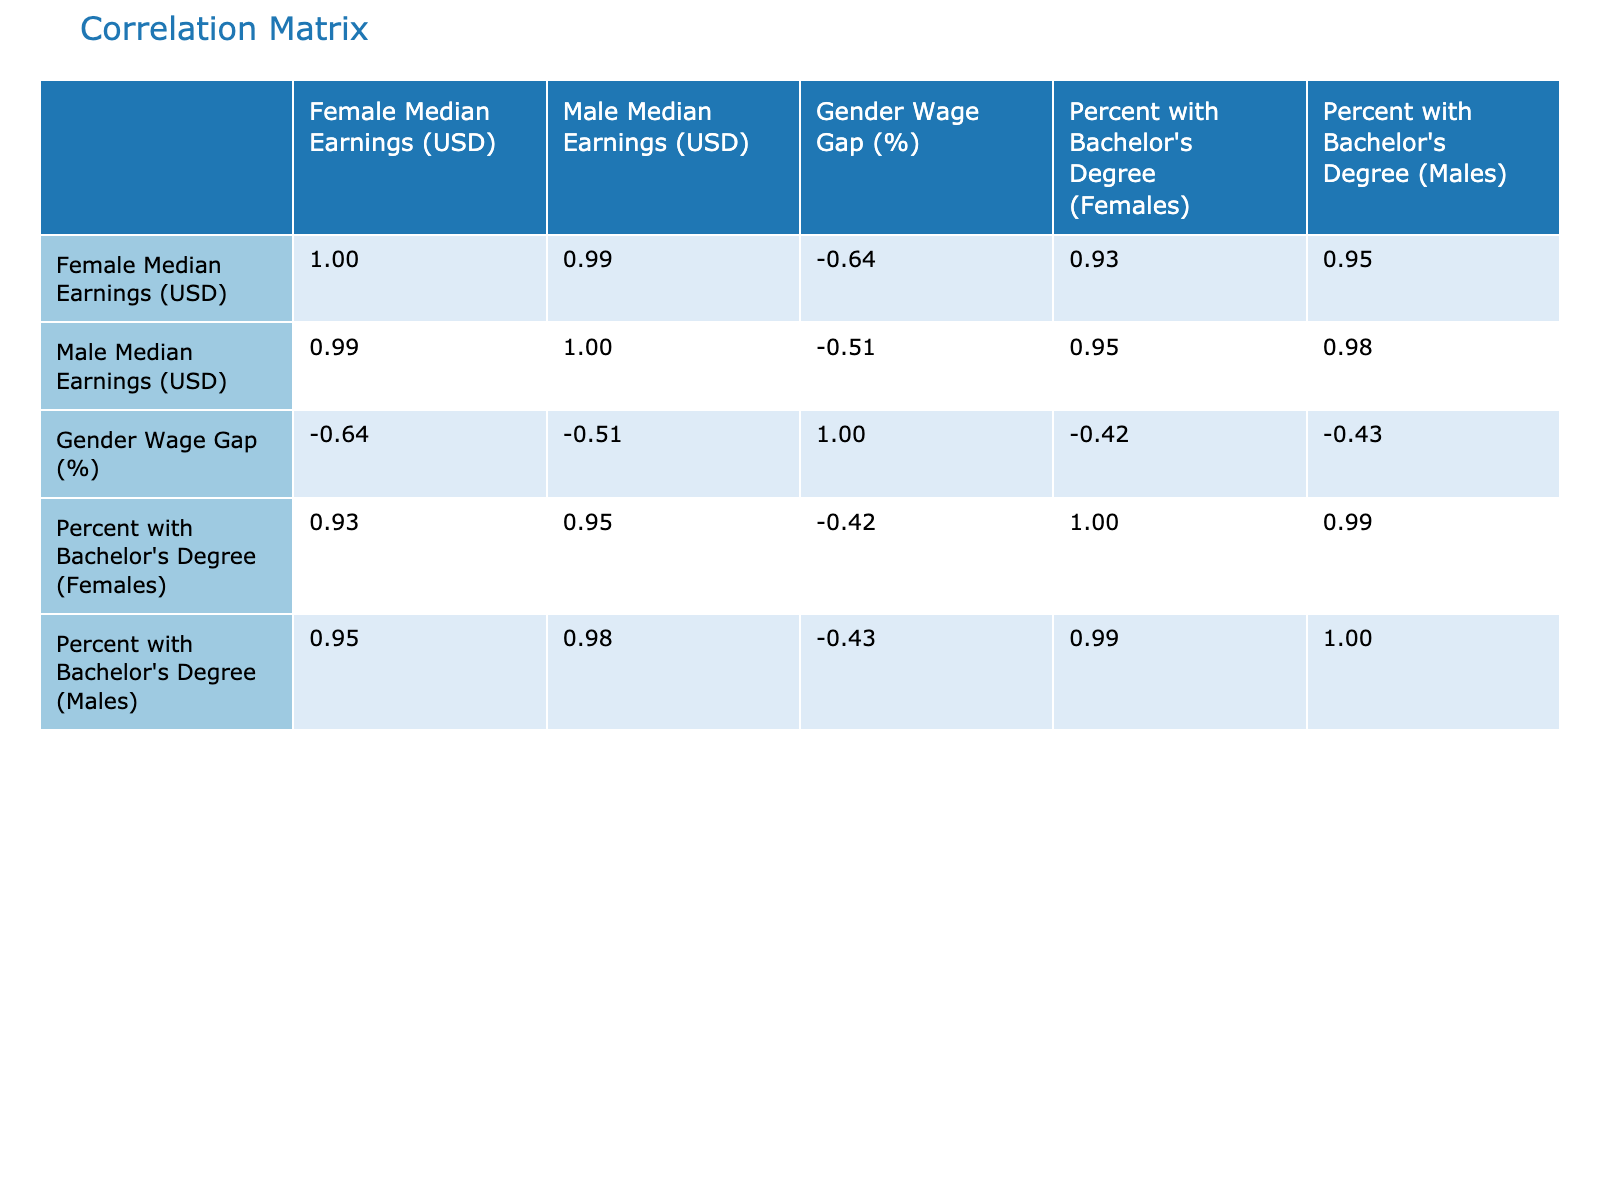What is the gender wage gap in Florida? Referring to the table, the gender wage gap for Florida is directly listed in the corresponding row. It states that the gender wage gap is 28.1%.
Answer: 28.1% Which state has the highest female median earnings? By checking the "Female Median Earnings (USD)" column, Massachusetts shows the highest value of 68000 USD.
Answer: Massachusetts What is the average percentage of males with a Bachelor's degree across all states? To find the average, we need to add the percent of males with a Bachelor's degree in each state (45 + 35 + 50 + 32 + 38 + 34 + 36 + 42 + 52 = 414) and divide by the number of states (9). Thus, 414 / 9 ≈ 46.00%.
Answer: 46.00% Is the gender wage gap positively correlated with the percentage of females with a Bachelor's degree? To determine the correlation, we check the correlation coefficient in the correlation matrix. The values for "Gender Wage Gap (%)" and "Percent with Bachelor's Degree (Females)" will provide insights on correlation. Since the correlation turns out to be negative, the answer is no.
Answer: No What is the difference between male and female median earnings in New York? From the table, the female median earnings in New York are 65000 USD, while male median earnings are 85000 USD. The difference is calculated as 85000 - 65000 = 20000 USD.
Answer: 20000 USD Which state has the lowest percentage of females with a Bachelor's degree? Looking at the "Percent with Bachelor's Degree (Females)" column, Florida shows the lowest value of 28%.
Answer: Florida How does the percentage of males with a Bachelor's degree in Massachusetts compare to the national average of 40%? The percentage of males with a Bachelor's degree in Massachusetts is 52%, which is higher than the national average of 40%.
Answer: Higher What is the correlation between female median earnings and the gender wage gap across the states? To find this, we refer to the correlation matrix. The correlation coefficient shows the relationship, and verifying it reveals a negative correlation (about -0.66). This indicates that as female median earnings increase, the gender wage gap generally decreases.
Answer: Negative correlation Is there a state where the gender wage gap is less than the average gender wage gap across all states? First, we need to calculate the average gender wage gap, which is roughly 25.4%. By comparing this with each state's gap, we find Texas has a gender wage gap of 21.4%, which is less than the average.
Answer: Yes 